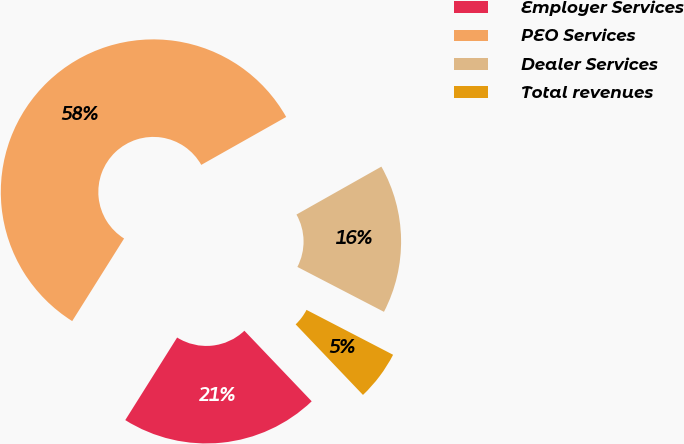Convert chart. <chart><loc_0><loc_0><loc_500><loc_500><pie_chart><fcel>Employer Services<fcel>PEO Services<fcel>Dealer Services<fcel>Total revenues<nl><fcel>21.05%<fcel>57.89%<fcel>15.79%<fcel>5.26%<nl></chart> 